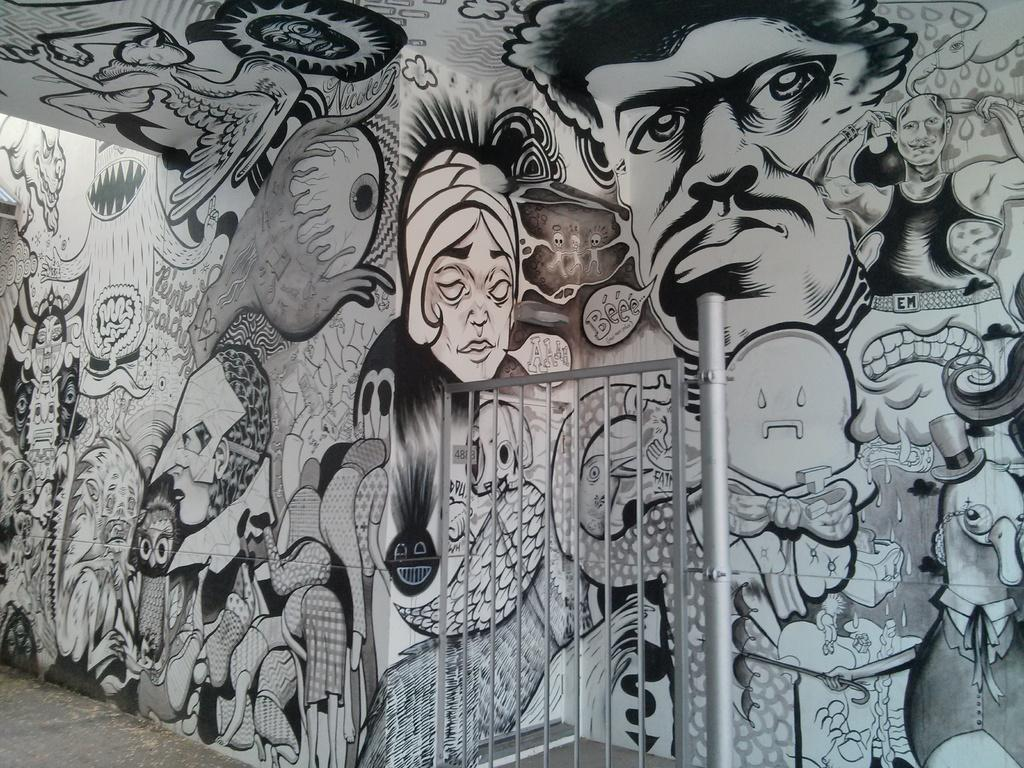What can be seen in the image? There is a wall in the image. What is on the wall? There is a painting on the wall. What type of church is depicted in the painting on the wall? There is no church depicted in the painting on the wall; the painting is not described in the provided facts. 